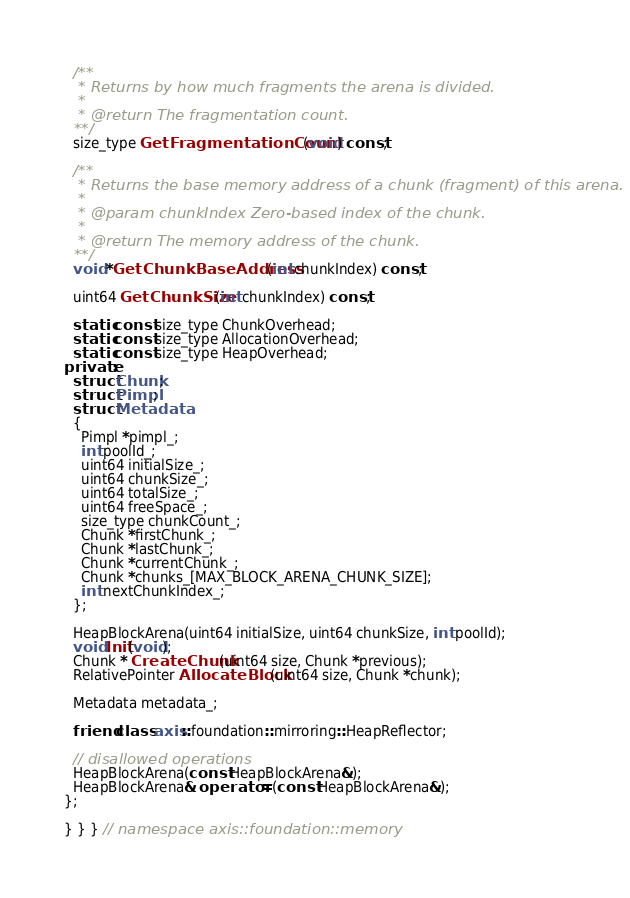Convert code to text. <code><loc_0><loc_0><loc_500><loc_500><_C++_>
  /**
   * Returns by how much fragments the arena is divided.
   *
   * @return The fragmentation count.
  **/
  size_type GetFragmentationCount(void) const;

  /**
   * Returns the base memory address of a chunk (fragment) of this arena.
   *
   * @param chunkIndex Zero-based index of the chunk.
   *
   * @return The memory address of the chunk.
  **/
  void *GetChunkBaseAddress(int chunkIndex) const;

  uint64 GetChunkSize(int chunkIndex) const;

  static const size_type ChunkOverhead;
  static const size_type AllocationOverhead;
  static const size_type HeapOverhead;
private:
  struct Chunk;
  struct Pimpl;
  struct Metadata
  {
    Pimpl *pimpl_;
    int poolId_;
    uint64 initialSize_;
    uint64 chunkSize_;
    uint64 totalSize_;
    uint64 freeSpace_;
    size_type chunkCount_;
    Chunk *firstChunk_;
    Chunk *lastChunk_;  
    Chunk *currentChunk_;
    Chunk *chunks_[MAX_BLOCK_ARENA_CHUNK_SIZE];
    int nextChunkIndex_;
  };

  HeapBlockArena(uint64 initialSize, uint64 chunkSize, int poolId);
  void Init(void);
  Chunk * CreateChunk(uint64 size, Chunk *previous);
  RelativePointer AllocateBlock(uint64 size, Chunk *chunk);

  Metadata metadata_;

  friend class axis::foundation::mirroring::HeapReflector;

  // disallowed operations
  HeapBlockArena(const HeapBlockArena&);
  HeapBlockArena& operator =(const HeapBlockArena&);
};

} } } // namespace axis::foundation::memory
</code> 